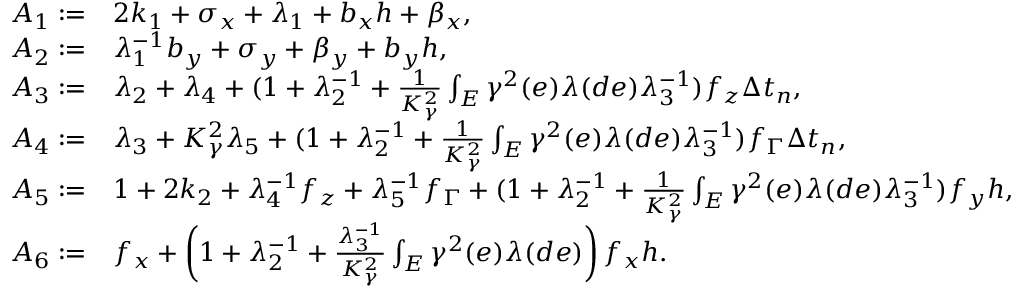Convert formula to latex. <formula><loc_0><loc_0><loc_500><loc_500>\begin{array} { r l } { A _ { 1 } \colon = } & { 2 k _ { 1 } + \sigma _ { x } + \lambda _ { 1 } + b _ { x } h + \beta _ { x } , } \\ { A _ { 2 } \colon = } & { \lambda _ { 1 } ^ { - 1 } b _ { y } + \sigma _ { y } + \beta _ { y } + b _ { y } h , } \\ { A _ { 3 } \colon = } & { \lambda _ { 2 } + \lambda _ { 4 } + ( 1 + \lambda _ { 2 } ^ { - 1 } + \frac { 1 } { K _ { \gamma } ^ { 2 } } \int _ { E } \gamma ^ { 2 } ( e ) \lambda ( d e ) \lambda _ { 3 } ^ { - 1 } ) f _ { z } \Delta t _ { n } , } \\ { A _ { 4 } \colon = } & { \lambda _ { 3 } + K _ { \gamma } ^ { 2 } \lambda _ { 5 } + ( 1 + \lambda _ { 2 } ^ { - 1 } + \frac { 1 } { K _ { \gamma } ^ { 2 } } \int _ { E } \gamma ^ { 2 } ( e ) \lambda ( d e ) \lambda _ { 3 } ^ { - 1 } ) f _ { \Gamma } \Delta t _ { n } , } \\ { A _ { 5 } \colon = } & { 1 + 2 k _ { 2 } + \lambda _ { 4 } ^ { - 1 } f _ { z } + \lambda _ { 5 } ^ { - 1 } f _ { \Gamma } + ( 1 + \lambda _ { 2 } ^ { - 1 } + \frac { 1 } { K _ { \gamma } ^ { 2 } } \int _ { E } \gamma ^ { 2 } ( e ) \lambda ( d e ) \lambda _ { 3 } ^ { - 1 } ) f _ { y } h , } \\ { A _ { 6 } \colon = } & { f _ { x } + \left ( 1 + \lambda _ { 2 } ^ { - 1 } + \frac { \lambda _ { 3 } ^ { - 1 } } { K _ { \gamma } ^ { 2 } } \int _ { E } \gamma ^ { 2 } ( e ) \lambda ( d e ) \right ) f _ { x } h . } \end{array}</formula> 